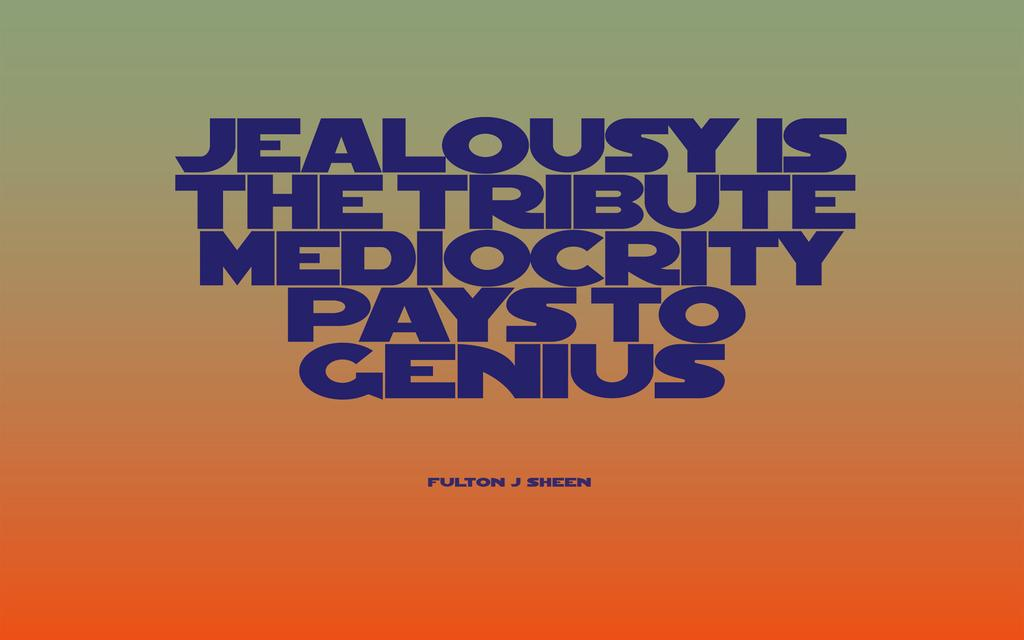<image>
Render a clear and concise summary of the photo. a fulton j sheen poster that says 'jealousy is the tribute mediocrity pays to genius' 